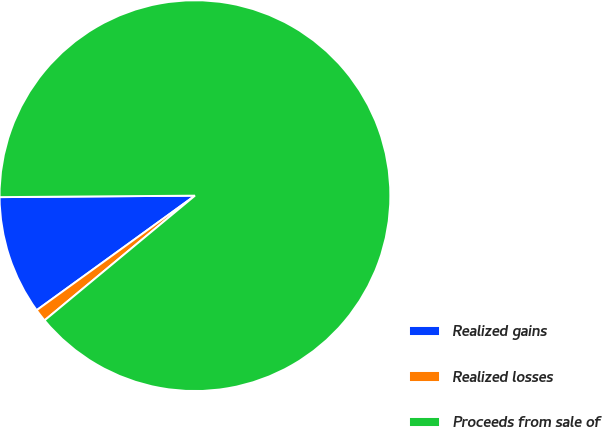<chart> <loc_0><loc_0><loc_500><loc_500><pie_chart><fcel>Realized gains<fcel>Realized losses<fcel>Proceeds from sale of<nl><fcel>9.85%<fcel>1.05%<fcel>89.1%<nl></chart> 